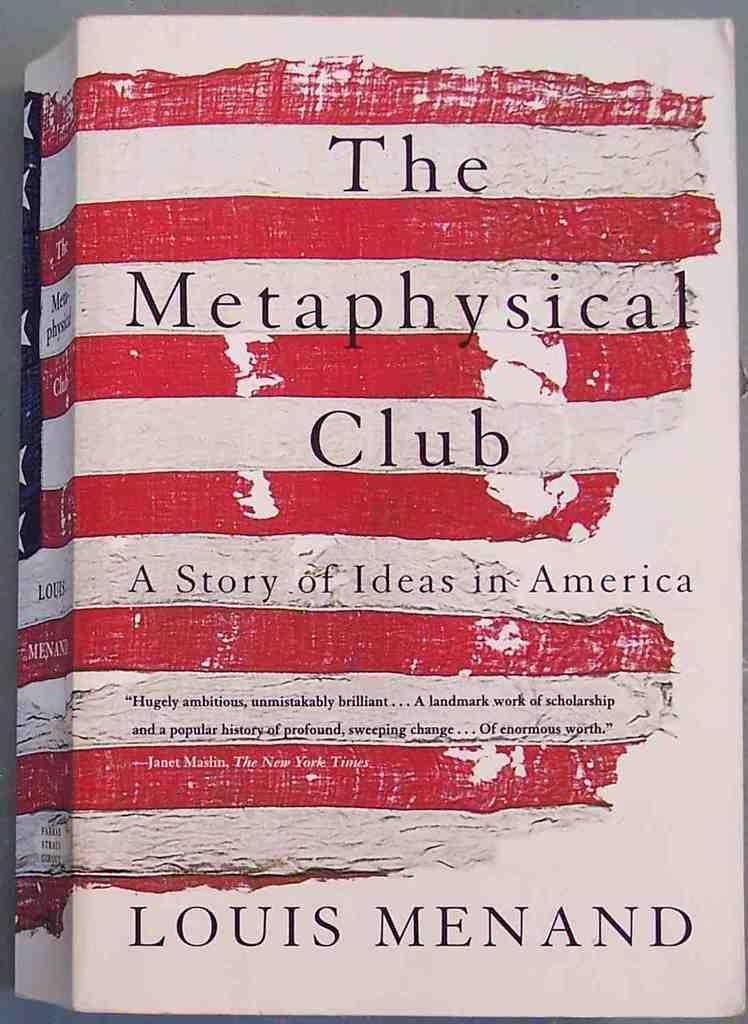Provide a one-sentence caption for the provided image. The book "The Metaphysical Club" is about ideas in America. 